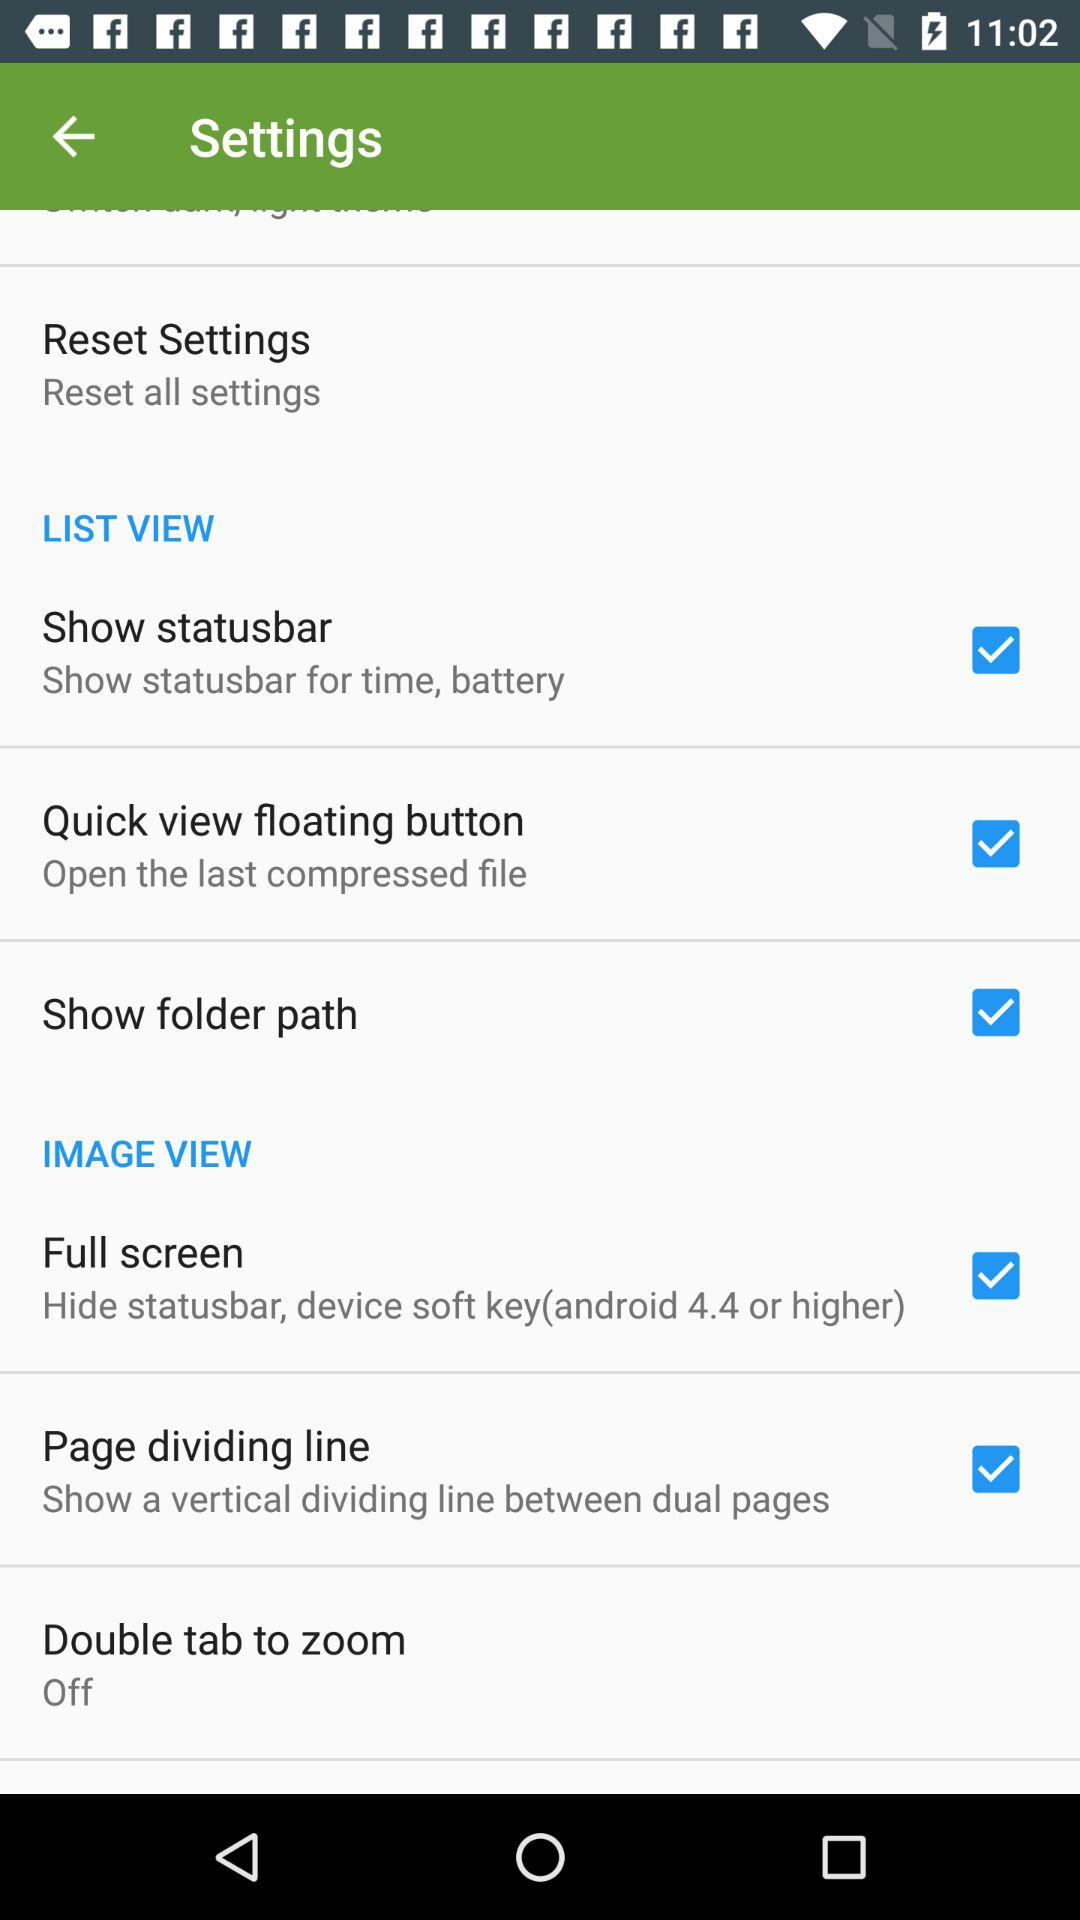What is the status of "Double tab to zoom"? Double tab to zoom status is "Off". 